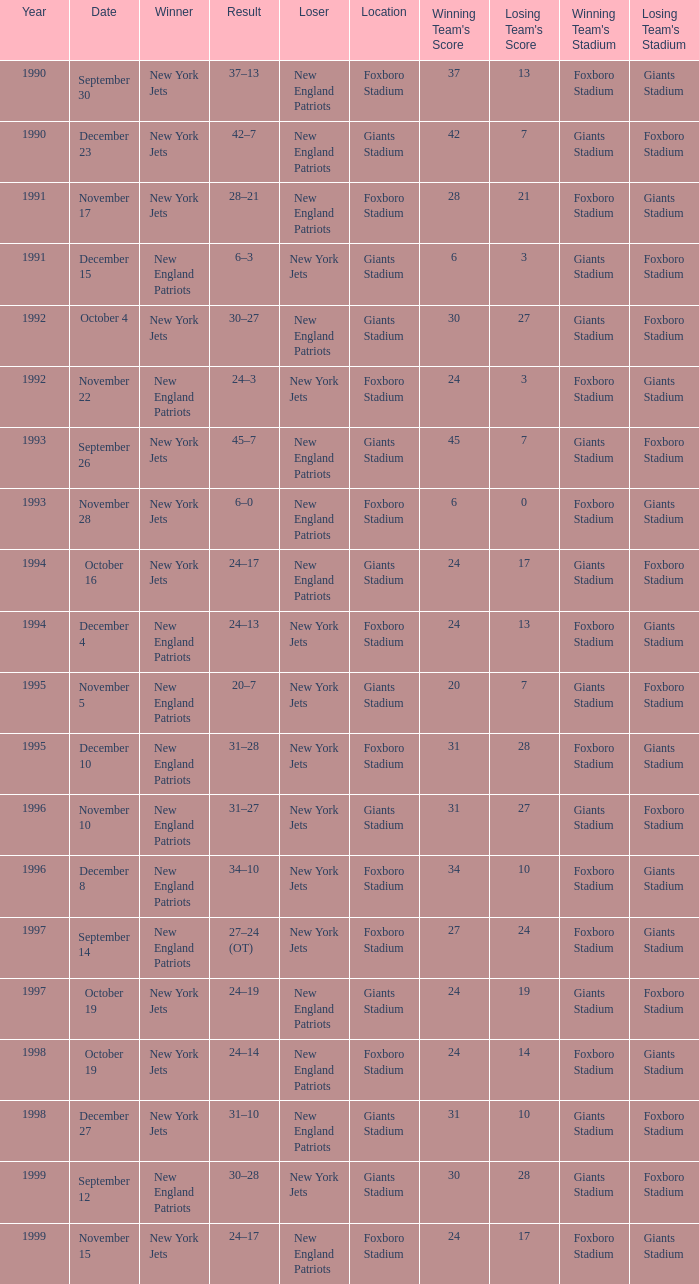What is the name of the Loser when the winner was new england patriots, and a Location of giants stadium, and a Result of 30–28? New York Jets. 